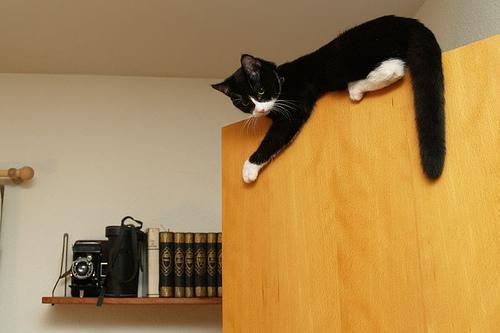How many items are made of wood?
Give a very brief answer. 2. How many black and gold volumes are visible?
Give a very brief answer. 6. 